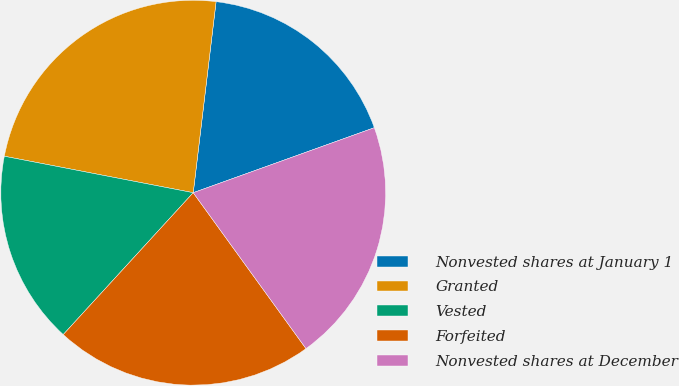Convert chart. <chart><loc_0><loc_0><loc_500><loc_500><pie_chart><fcel>Nonvested shares at January 1<fcel>Granted<fcel>Vested<fcel>Forfeited<fcel>Nonvested shares at December<nl><fcel>17.62%<fcel>23.86%<fcel>16.23%<fcel>21.77%<fcel>20.52%<nl></chart> 